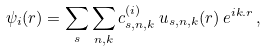Convert formula to latex. <formula><loc_0><loc_0><loc_500><loc_500>\psi _ { i } ( { r } ) = \sum _ { s } \sum _ { n , k } c _ { s , n , k } ^ { ( i ) } \, u _ { s , n , k } ( { r } ) \, e ^ { i { k . r } } \, ,</formula> 